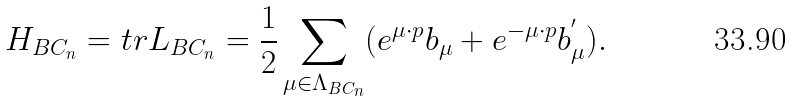Convert formula to latex. <formula><loc_0><loc_0><loc_500><loc_500>H _ { B C _ { n } } = t r L _ { B C _ { n } } = \frac { 1 } { 2 } \sum _ { \mu \in \Lambda _ { B C _ { n } } } ( e ^ { \mu \cdot p } b _ { \mu } + e ^ { - \mu \cdot p } b _ { \mu } ^ { ^ { \prime } } ) .</formula> 